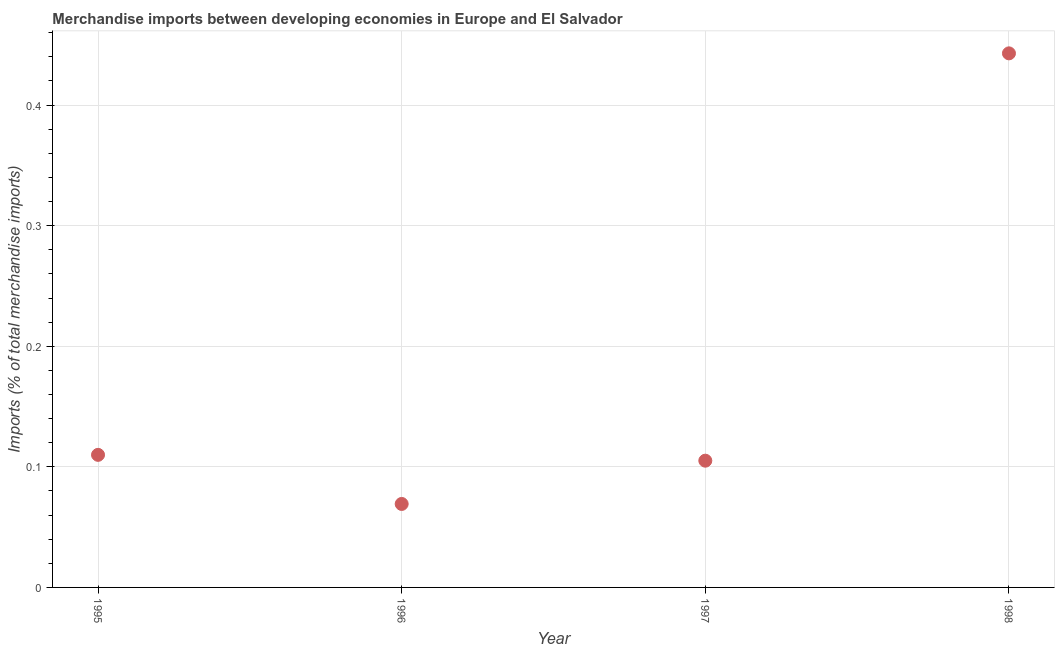What is the merchandise imports in 1998?
Offer a terse response. 0.44. Across all years, what is the maximum merchandise imports?
Provide a succinct answer. 0.44. Across all years, what is the minimum merchandise imports?
Your answer should be compact. 0.07. In which year was the merchandise imports minimum?
Provide a short and direct response. 1996. What is the sum of the merchandise imports?
Provide a short and direct response. 0.73. What is the difference between the merchandise imports in 1995 and 1998?
Your response must be concise. -0.33. What is the average merchandise imports per year?
Make the answer very short. 0.18. What is the median merchandise imports?
Ensure brevity in your answer.  0.11. Do a majority of the years between 1995 and 1998 (inclusive) have merchandise imports greater than 0.14 %?
Make the answer very short. No. What is the ratio of the merchandise imports in 1996 to that in 1998?
Offer a terse response. 0.16. What is the difference between the highest and the second highest merchandise imports?
Give a very brief answer. 0.33. What is the difference between the highest and the lowest merchandise imports?
Keep it short and to the point. 0.37. In how many years, is the merchandise imports greater than the average merchandise imports taken over all years?
Your answer should be compact. 1. Does the graph contain any zero values?
Make the answer very short. No. What is the title of the graph?
Your answer should be compact. Merchandise imports between developing economies in Europe and El Salvador. What is the label or title of the Y-axis?
Offer a terse response. Imports (% of total merchandise imports). What is the Imports (% of total merchandise imports) in 1995?
Offer a very short reply. 0.11. What is the Imports (% of total merchandise imports) in 1996?
Ensure brevity in your answer.  0.07. What is the Imports (% of total merchandise imports) in 1997?
Make the answer very short. 0.11. What is the Imports (% of total merchandise imports) in 1998?
Your answer should be compact. 0.44. What is the difference between the Imports (% of total merchandise imports) in 1995 and 1996?
Your answer should be very brief. 0.04. What is the difference between the Imports (% of total merchandise imports) in 1995 and 1997?
Your answer should be compact. 0. What is the difference between the Imports (% of total merchandise imports) in 1995 and 1998?
Offer a terse response. -0.33. What is the difference between the Imports (% of total merchandise imports) in 1996 and 1997?
Provide a succinct answer. -0.04. What is the difference between the Imports (% of total merchandise imports) in 1996 and 1998?
Your answer should be compact. -0.37. What is the difference between the Imports (% of total merchandise imports) in 1997 and 1998?
Offer a very short reply. -0.34. What is the ratio of the Imports (% of total merchandise imports) in 1995 to that in 1996?
Provide a succinct answer. 1.59. What is the ratio of the Imports (% of total merchandise imports) in 1995 to that in 1997?
Your response must be concise. 1.05. What is the ratio of the Imports (% of total merchandise imports) in 1995 to that in 1998?
Provide a succinct answer. 0.25. What is the ratio of the Imports (% of total merchandise imports) in 1996 to that in 1997?
Give a very brief answer. 0.66. What is the ratio of the Imports (% of total merchandise imports) in 1996 to that in 1998?
Your answer should be very brief. 0.16. What is the ratio of the Imports (% of total merchandise imports) in 1997 to that in 1998?
Offer a very short reply. 0.24. 